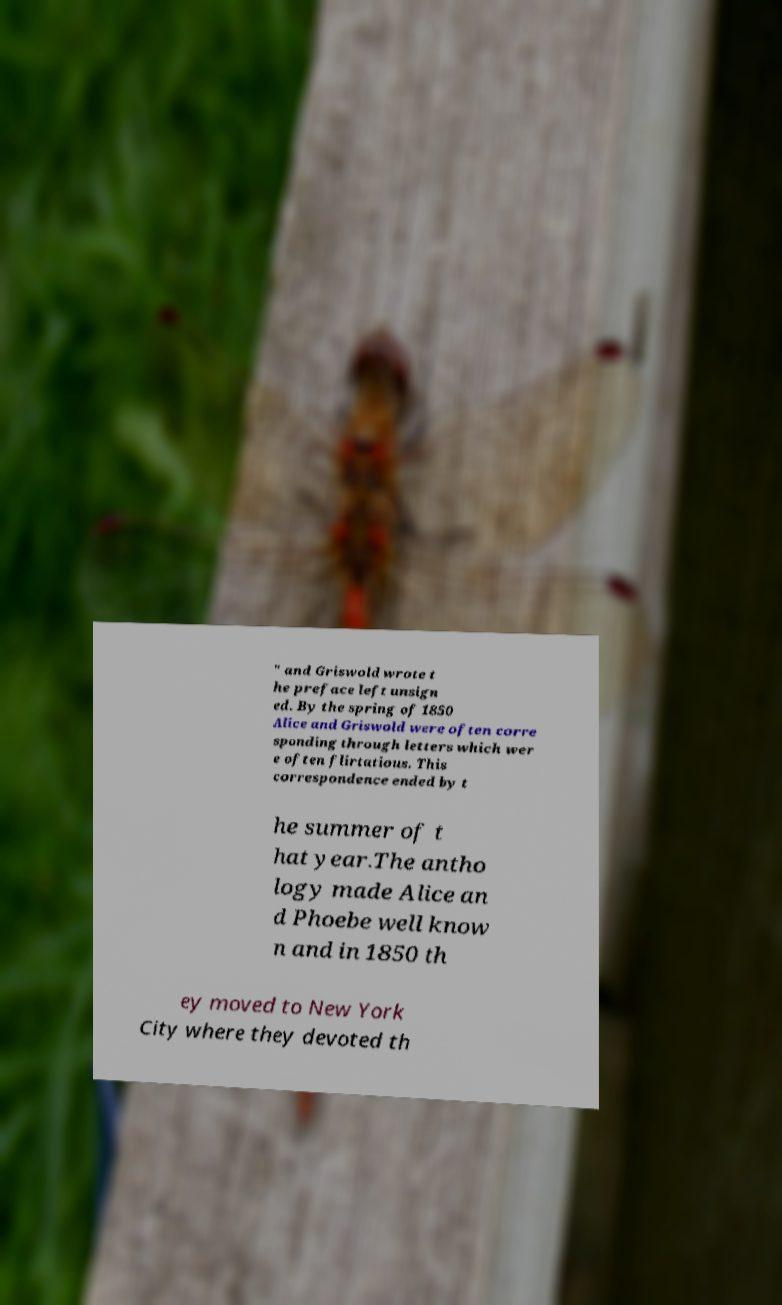Please identify and transcribe the text found in this image. " and Griswold wrote t he preface left unsign ed. By the spring of 1850 Alice and Griswold were often corre sponding through letters which wer e often flirtatious. This correspondence ended by t he summer of t hat year.The antho logy made Alice an d Phoebe well know n and in 1850 th ey moved to New York City where they devoted th 